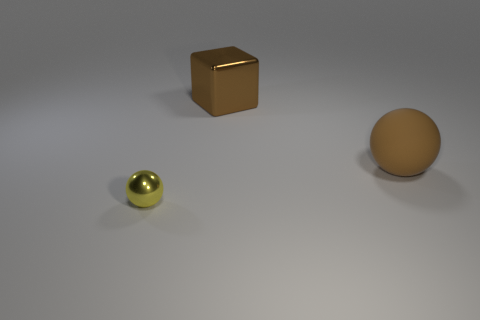Add 3 brown rubber spheres. How many objects exist? 6 Subtract all yellow spheres. How many spheres are left? 1 Add 3 tiny yellow spheres. How many tiny yellow spheres are left? 4 Add 2 cyan cylinders. How many cyan cylinders exist? 2 Subtract 0 purple cylinders. How many objects are left? 3 Subtract all balls. How many objects are left? 1 Subtract 1 spheres. How many spheres are left? 1 Subtract all blue cubes. Subtract all purple cylinders. How many cubes are left? 1 Subtract all purple balls. How many gray cubes are left? 0 Subtract all large purple metal cubes. Subtract all big cubes. How many objects are left? 2 